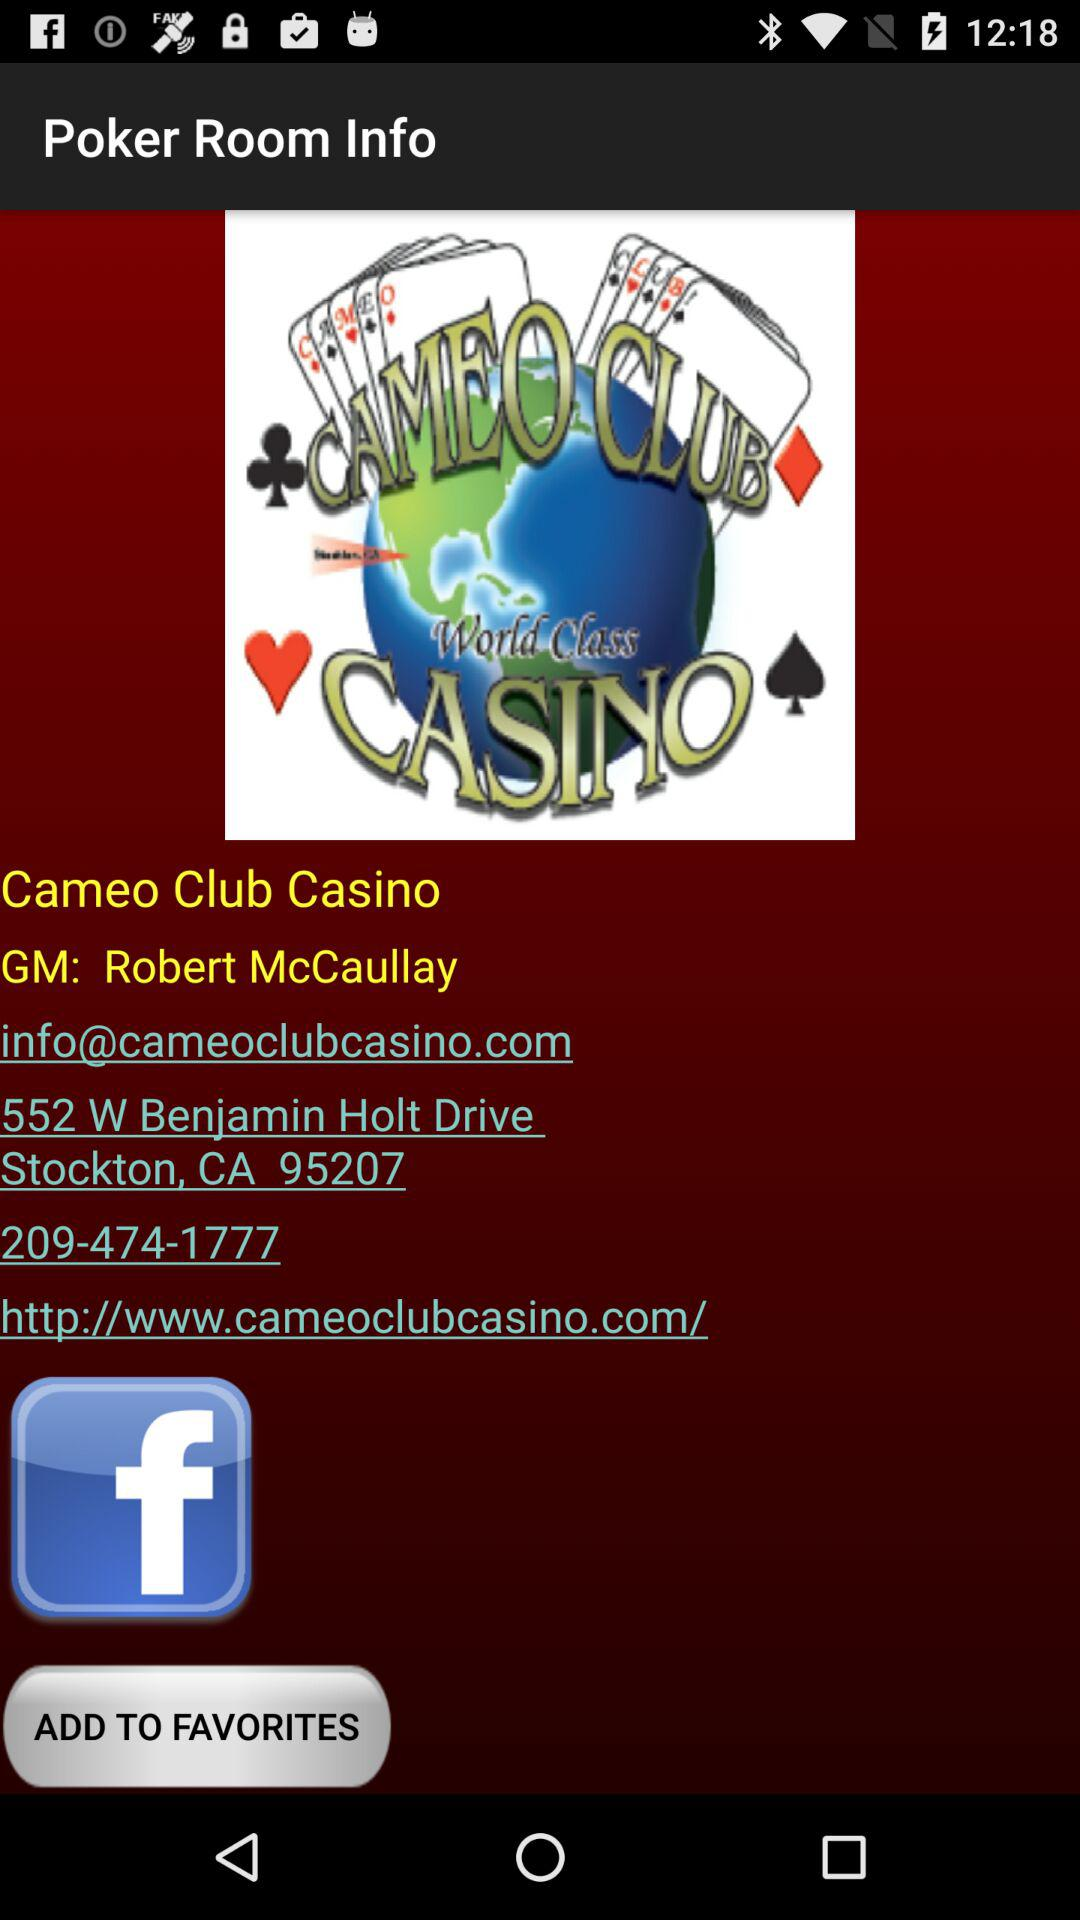What is the Cameo Club casino's address? The address is 552 W Benjamin Holt Drive, Stockton, CA 95207. 